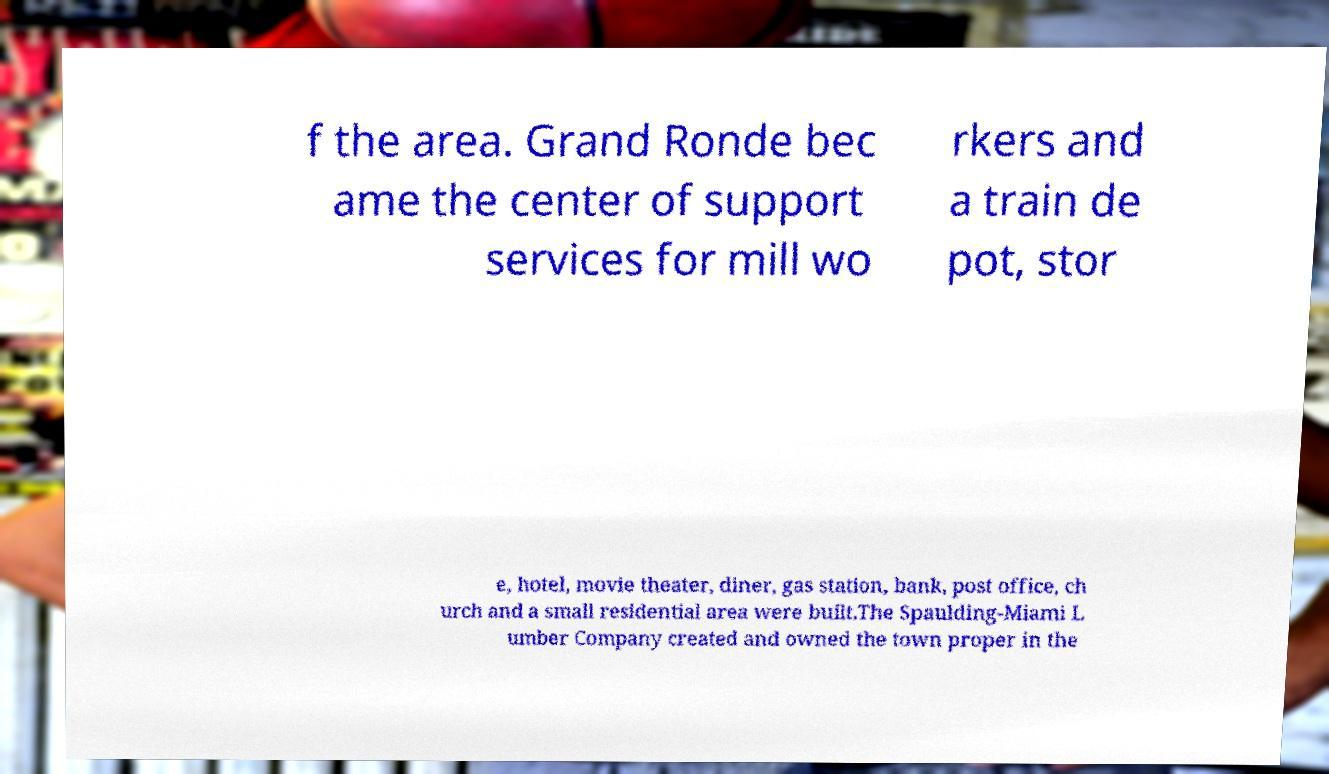Could you assist in decoding the text presented in this image and type it out clearly? f the area. Grand Ronde bec ame the center of support services for mill wo rkers and a train de pot, stor e, hotel, movie theater, diner, gas station, bank, post office, ch urch and a small residential area were built.The Spaulding-Miami L umber Company created and owned the town proper in the 